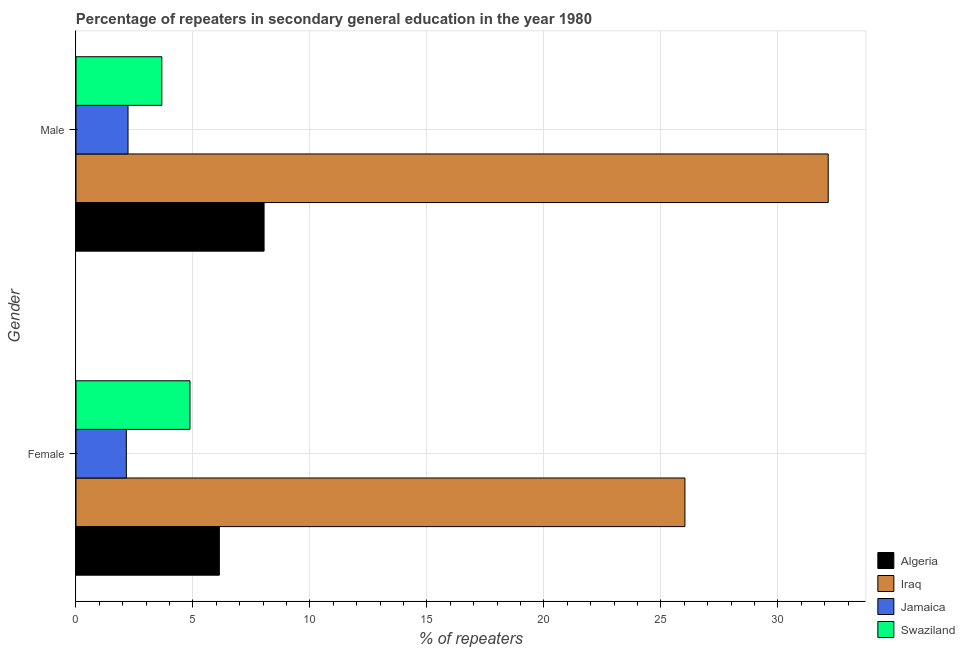How many groups of bars are there?
Your response must be concise. 2. Are the number of bars per tick equal to the number of legend labels?
Make the answer very short. Yes. What is the label of the 2nd group of bars from the top?
Make the answer very short. Female. What is the percentage of male repeaters in Algeria?
Provide a succinct answer. 8.04. Across all countries, what is the maximum percentage of male repeaters?
Your response must be concise. 32.15. Across all countries, what is the minimum percentage of male repeaters?
Provide a short and direct response. 2.22. In which country was the percentage of female repeaters maximum?
Offer a terse response. Iraq. In which country was the percentage of female repeaters minimum?
Ensure brevity in your answer.  Jamaica. What is the total percentage of female repeaters in the graph?
Offer a very short reply. 39.18. What is the difference between the percentage of male repeaters in Iraq and that in Algeria?
Your answer should be very brief. 24.11. What is the difference between the percentage of female repeaters in Jamaica and the percentage of male repeaters in Iraq?
Give a very brief answer. -30. What is the average percentage of female repeaters per country?
Make the answer very short. 9.8. What is the difference between the percentage of female repeaters and percentage of male repeaters in Algeria?
Keep it short and to the point. -1.91. In how many countries, is the percentage of female repeaters greater than 11 %?
Your answer should be very brief. 1. What is the ratio of the percentage of male repeaters in Swaziland to that in Iraq?
Offer a terse response. 0.11. In how many countries, is the percentage of male repeaters greater than the average percentage of male repeaters taken over all countries?
Your answer should be compact. 1. What does the 3rd bar from the top in Male represents?
Give a very brief answer. Iraq. What does the 2nd bar from the bottom in Male represents?
Offer a very short reply. Iraq. Are all the bars in the graph horizontal?
Ensure brevity in your answer.  Yes. How many countries are there in the graph?
Make the answer very short. 4. Are the values on the major ticks of X-axis written in scientific E-notation?
Your answer should be very brief. No. How are the legend labels stacked?
Provide a short and direct response. Vertical. What is the title of the graph?
Your answer should be compact. Percentage of repeaters in secondary general education in the year 1980. Does "Kenya" appear as one of the legend labels in the graph?
Keep it short and to the point. No. What is the label or title of the X-axis?
Your response must be concise. % of repeaters. What is the % of repeaters of Algeria in Female?
Provide a succinct answer. 6.13. What is the % of repeaters in Iraq in Female?
Your response must be concise. 26.03. What is the % of repeaters in Jamaica in Female?
Provide a short and direct response. 2.15. What is the % of repeaters of Swaziland in Female?
Your answer should be compact. 4.87. What is the % of repeaters of Algeria in Male?
Offer a very short reply. 8.04. What is the % of repeaters of Iraq in Male?
Your answer should be compact. 32.15. What is the % of repeaters of Jamaica in Male?
Ensure brevity in your answer.  2.22. What is the % of repeaters in Swaziland in Male?
Keep it short and to the point. 3.67. Across all Gender, what is the maximum % of repeaters in Algeria?
Your response must be concise. 8.04. Across all Gender, what is the maximum % of repeaters of Iraq?
Provide a short and direct response. 32.15. Across all Gender, what is the maximum % of repeaters in Jamaica?
Ensure brevity in your answer.  2.22. Across all Gender, what is the maximum % of repeaters of Swaziland?
Offer a terse response. 4.87. Across all Gender, what is the minimum % of repeaters in Algeria?
Your response must be concise. 6.13. Across all Gender, what is the minimum % of repeaters in Iraq?
Ensure brevity in your answer.  26.03. Across all Gender, what is the minimum % of repeaters in Jamaica?
Ensure brevity in your answer.  2.15. Across all Gender, what is the minimum % of repeaters in Swaziland?
Provide a succinct answer. 3.67. What is the total % of repeaters in Algeria in the graph?
Provide a succinct answer. 14.17. What is the total % of repeaters of Iraq in the graph?
Your response must be concise. 58.18. What is the total % of repeaters in Jamaica in the graph?
Your answer should be very brief. 4.38. What is the total % of repeaters in Swaziland in the graph?
Keep it short and to the point. 8.54. What is the difference between the % of repeaters of Algeria in Female and that in Male?
Your answer should be compact. -1.91. What is the difference between the % of repeaters in Iraq in Female and that in Male?
Make the answer very short. -6.13. What is the difference between the % of repeaters in Jamaica in Female and that in Male?
Give a very brief answer. -0.07. What is the difference between the % of repeaters of Swaziland in Female and that in Male?
Keep it short and to the point. 1.2. What is the difference between the % of repeaters in Algeria in Female and the % of repeaters in Iraq in Male?
Provide a succinct answer. -26.02. What is the difference between the % of repeaters in Algeria in Female and the % of repeaters in Jamaica in Male?
Provide a short and direct response. 3.9. What is the difference between the % of repeaters of Algeria in Female and the % of repeaters of Swaziland in Male?
Your answer should be compact. 2.46. What is the difference between the % of repeaters in Iraq in Female and the % of repeaters in Jamaica in Male?
Ensure brevity in your answer.  23.8. What is the difference between the % of repeaters of Iraq in Female and the % of repeaters of Swaziland in Male?
Offer a very short reply. 22.36. What is the difference between the % of repeaters of Jamaica in Female and the % of repeaters of Swaziland in Male?
Your response must be concise. -1.52. What is the average % of repeaters of Algeria per Gender?
Keep it short and to the point. 7.08. What is the average % of repeaters of Iraq per Gender?
Your answer should be compact. 29.09. What is the average % of repeaters in Jamaica per Gender?
Ensure brevity in your answer.  2.19. What is the average % of repeaters in Swaziland per Gender?
Offer a terse response. 4.27. What is the difference between the % of repeaters of Algeria and % of repeaters of Iraq in Female?
Provide a succinct answer. -19.9. What is the difference between the % of repeaters in Algeria and % of repeaters in Jamaica in Female?
Your response must be concise. 3.98. What is the difference between the % of repeaters of Algeria and % of repeaters of Swaziland in Female?
Provide a succinct answer. 1.26. What is the difference between the % of repeaters of Iraq and % of repeaters of Jamaica in Female?
Offer a terse response. 23.87. What is the difference between the % of repeaters of Iraq and % of repeaters of Swaziland in Female?
Your answer should be very brief. 21.15. What is the difference between the % of repeaters in Jamaica and % of repeaters in Swaziland in Female?
Give a very brief answer. -2.72. What is the difference between the % of repeaters in Algeria and % of repeaters in Iraq in Male?
Make the answer very short. -24.11. What is the difference between the % of repeaters in Algeria and % of repeaters in Jamaica in Male?
Make the answer very short. 5.81. What is the difference between the % of repeaters of Algeria and % of repeaters of Swaziland in Male?
Make the answer very short. 4.37. What is the difference between the % of repeaters in Iraq and % of repeaters in Jamaica in Male?
Offer a terse response. 29.93. What is the difference between the % of repeaters of Iraq and % of repeaters of Swaziland in Male?
Your answer should be compact. 28.48. What is the difference between the % of repeaters in Jamaica and % of repeaters in Swaziland in Male?
Keep it short and to the point. -1.44. What is the ratio of the % of repeaters of Algeria in Female to that in Male?
Provide a short and direct response. 0.76. What is the ratio of the % of repeaters of Iraq in Female to that in Male?
Your answer should be compact. 0.81. What is the ratio of the % of repeaters of Jamaica in Female to that in Male?
Give a very brief answer. 0.97. What is the ratio of the % of repeaters in Swaziland in Female to that in Male?
Make the answer very short. 1.33. What is the difference between the highest and the second highest % of repeaters in Algeria?
Your response must be concise. 1.91. What is the difference between the highest and the second highest % of repeaters of Iraq?
Your answer should be very brief. 6.13. What is the difference between the highest and the second highest % of repeaters in Jamaica?
Give a very brief answer. 0.07. What is the difference between the highest and the second highest % of repeaters in Swaziland?
Your answer should be very brief. 1.2. What is the difference between the highest and the lowest % of repeaters of Algeria?
Give a very brief answer. 1.91. What is the difference between the highest and the lowest % of repeaters of Iraq?
Ensure brevity in your answer.  6.13. What is the difference between the highest and the lowest % of repeaters of Jamaica?
Make the answer very short. 0.07. What is the difference between the highest and the lowest % of repeaters of Swaziland?
Offer a very short reply. 1.2. 